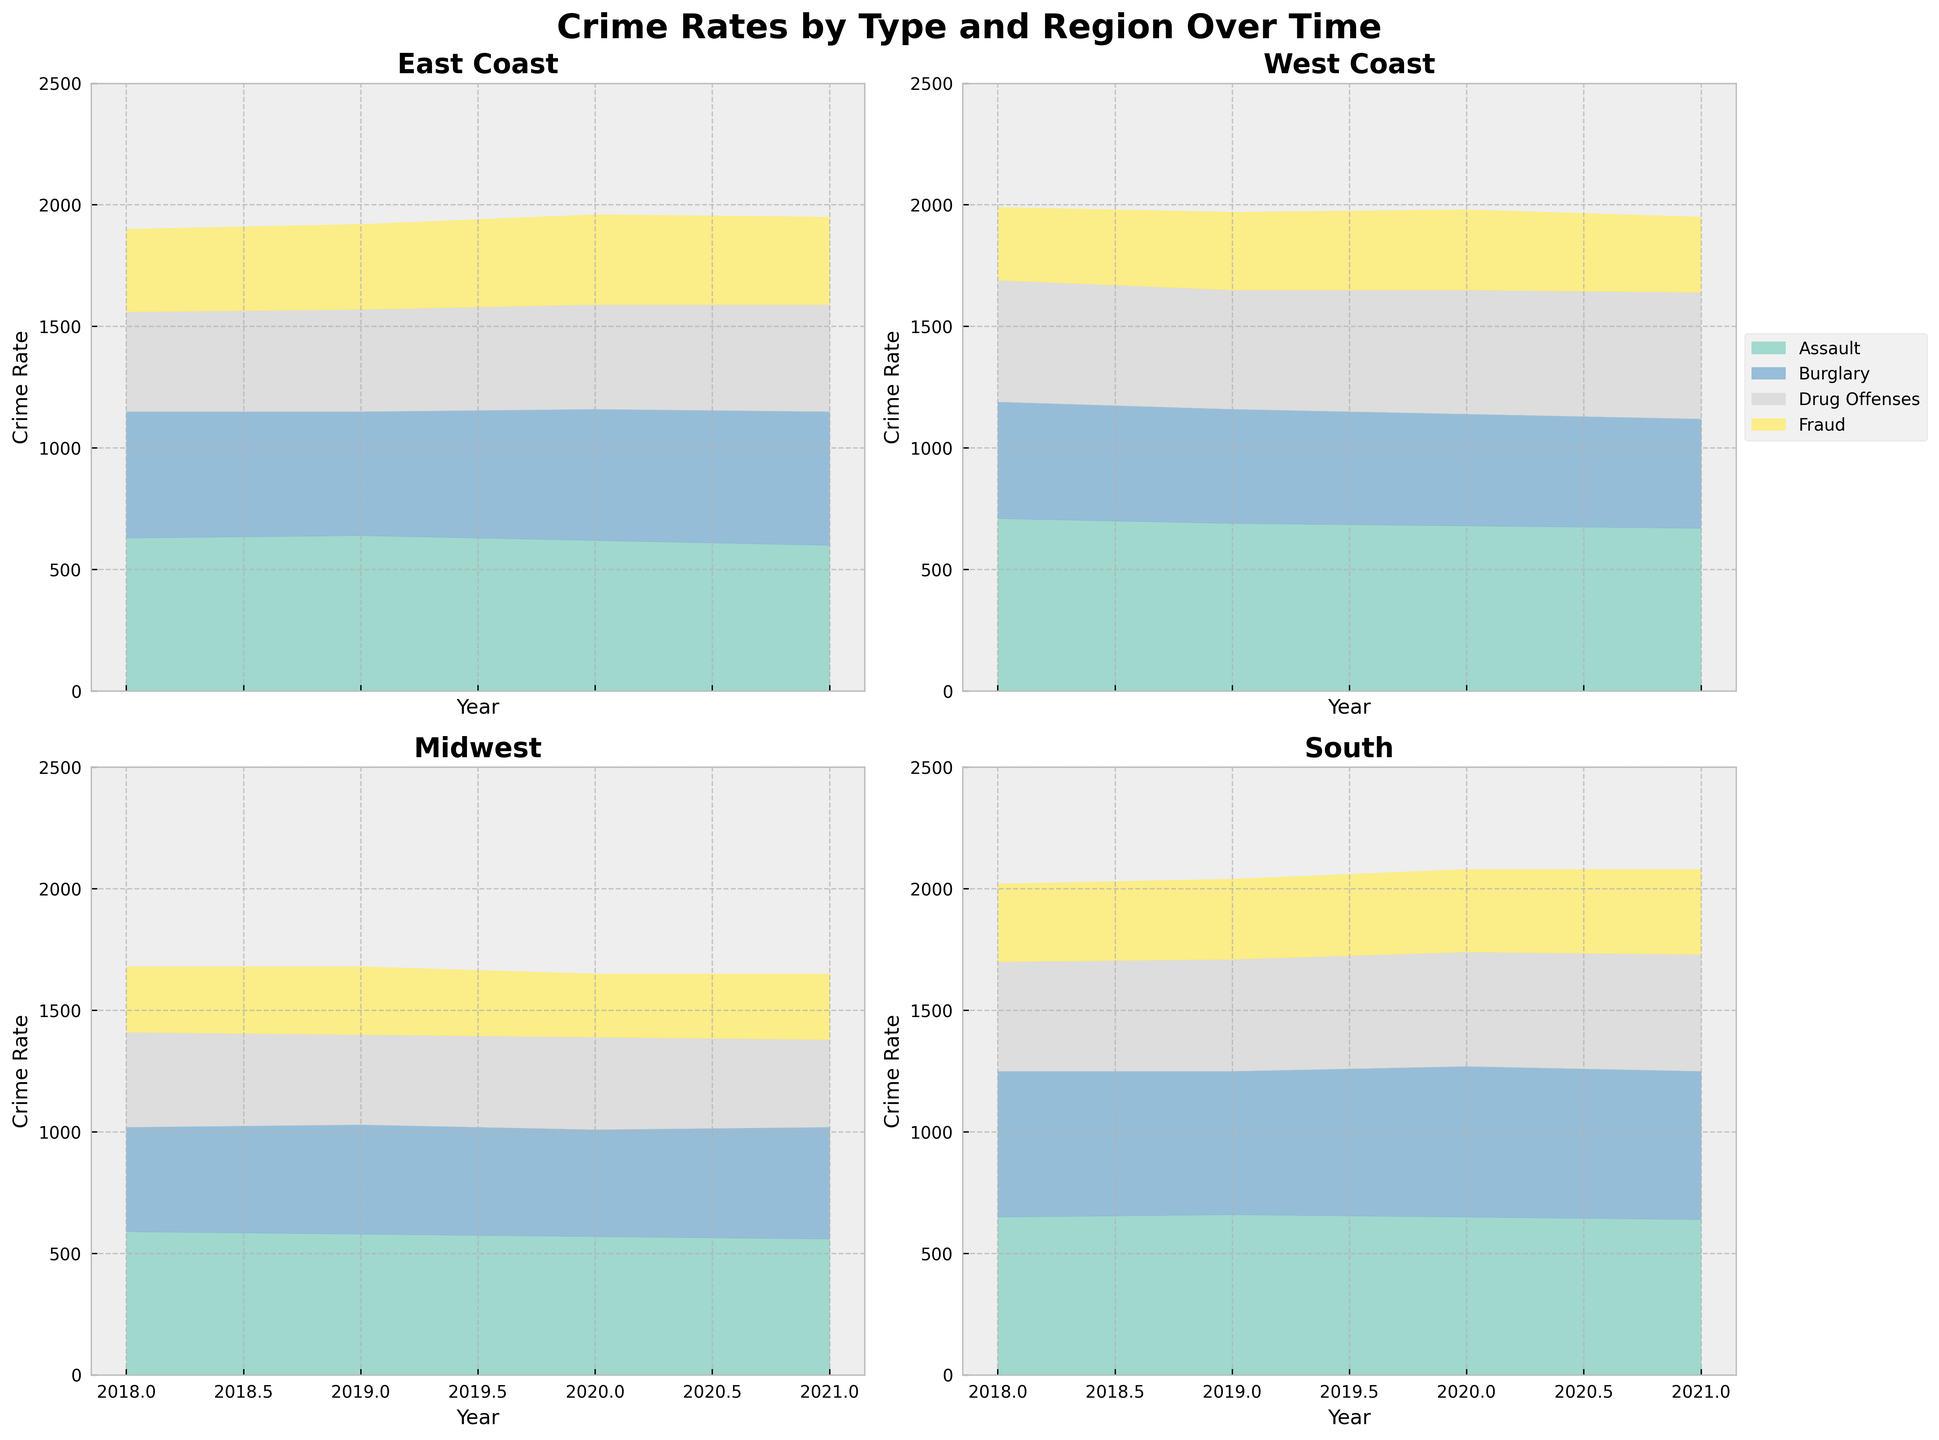What is the title of the chart? The title of the chart is located at the top center. It says "Crime Rates by Type and Region Over Time".
Answer: Crime Rates by Type and Region Over Time Which crime type has the highest rate on the East Coast in 2021? To identify the crime with the highest rate, look at the area with the largest vertical distance at the highest point in 2021. The crime type with the highest rate is Assault.
Answer: Assault What is the trend of Burglary rates on the South from 2018 to 2021? Trace the area corresponding to Burglary in the South subplot from 2018 to 2021. The Burglary rate starts at 600, slightly decreases to 590, then increases to 620, and finally slightly decreases to 610 in 2021.
Answer: Fluctuating with a slight overall increase Which region has the highest total crime rate in 2020? Sum the heights of all crime types (Assault, Burglary, Drug Offenses, Fraud) for each region in 2020. The South region has the highest overall height, indicating the highest total crime rate.
Answer: South How does the Fraud crime rate trend on the West Coast compare from 2018 to 2021? Compare the Fraud areas in the West Coast subplot from 2018 to 2021. The Fraud rate starts at 300, increases to 320, then 330, and decreases to 310 in 2021.
Answer: Generally increasing with a dip in 2021 What is the difference in Drug Offenses rates between the Midwest and East Coast in 2020? Find the Drug Offenses areas for both regions in 2020 and note their heights. Midwest is at 380 and East Coast is at 430. The difference is 430 - 380.
Answer: 50 Which region showed the most consistent Assault rate from 2018 to 2021? Study the area for Assault in each region's subplot from 2018 to 2021. The Midwest region shows the least variation with rates of 590, 580, 570, and 560.
Answer: Midwest What is the total crime rate for all types on the East Coast in 2021? Sum the heights of all crime types in the East Coast subplot for 2021. The rates are 600 (Assault) + 550 (Burglary) + 440 (Drug Offenses) + 360 (Fraud).
Answer: 1950 Which regions have increasing Burglary rates between 2018 and 2021? Compare the Burglary areas from 2018 to 2021 in each subplot. Both the East Coast and South regions have increasing Burglary rates.
Answer: East Coast and South 